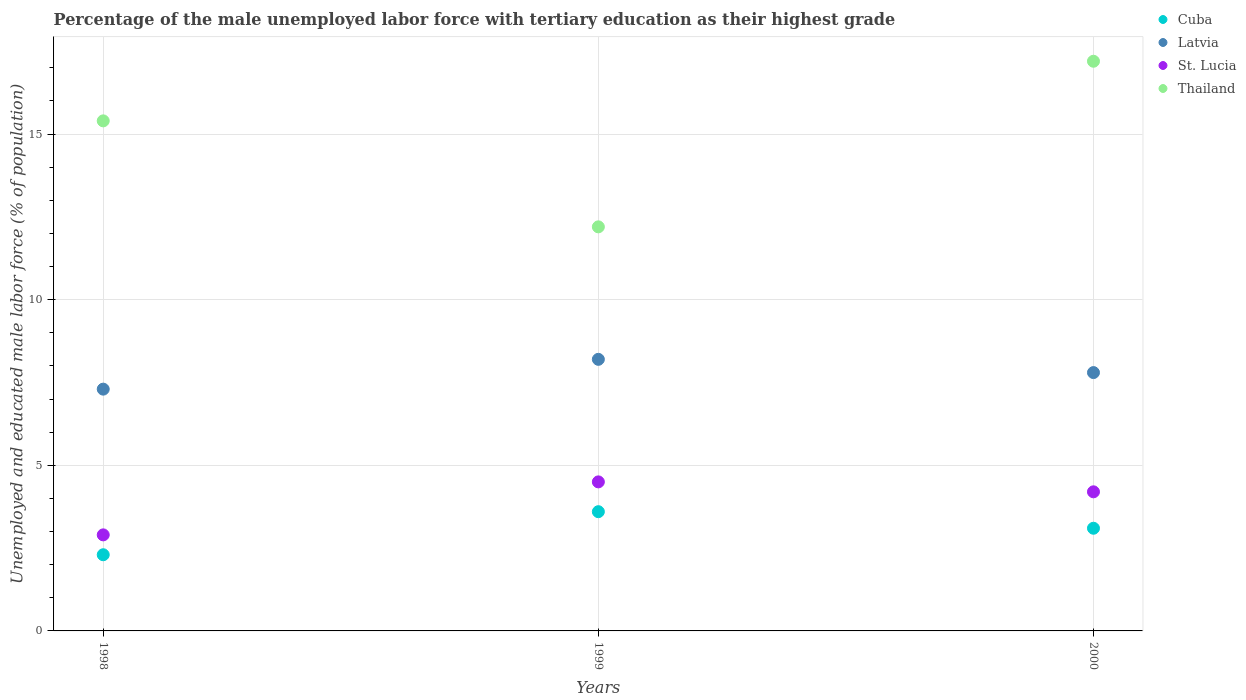What is the percentage of the unemployed male labor force with tertiary education in Latvia in 1998?
Your answer should be very brief. 7.3. Across all years, what is the maximum percentage of the unemployed male labor force with tertiary education in Cuba?
Your answer should be very brief. 3.6. Across all years, what is the minimum percentage of the unemployed male labor force with tertiary education in Thailand?
Give a very brief answer. 12.2. What is the total percentage of the unemployed male labor force with tertiary education in Cuba in the graph?
Provide a short and direct response. 9. What is the difference between the percentage of the unemployed male labor force with tertiary education in Cuba in 1998 and that in 1999?
Your answer should be very brief. -1.3. What is the difference between the percentage of the unemployed male labor force with tertiary education in Latvia in 1998 and the percentage of the unemployed male labor force with tertiary education in Cuba in 1999?
Your answer should be compact. 3.7. What is the average percentage of the unemployed male labor force with tertiary education in Latvia per year?
Provide a short and direct response. 7.77. In the year 2000, what is the difference between the percentage of the unemployed male labor force with tertiary education in Latvia and percentage of the unemployed male labor force with tertiary education in Cuba?
Provide a short and direct response. 4.7. What is the ratio of the percentage of the unemployed male labor force with tertiary education in Latvia in 1999 to that in 2000?
Keep it short and to the point. 1.05. What is the difference between the highest and the second highest percentage of the unemployed male labor force with tertiary education in Latvia?
Your answer should be very brief. 0.4. What is the difference between the highest and the lowest percentage of the unemployed male labor force with tertiary education in Thailand?
Your answer should be compact. 5. Is it the case that in every year, the sum of the percentage of the unemployed male labor force with tertiary education in Cuba and percentage of the unemployed male labor force with tertiary education in St. Lucia  is greater than the sum of percentage of the unemployed male labor force with tertiary education in Latvia and percentage of the unemployed male labor force with tertiary education in Thailand?
Make the answer very short. No. Is it the case that in every year, the sum of the percentage of the unemployed male labor force with tertiary education in St. Lucia and percentage of the unemployed male labor force with tertiary education in Cuba  is greater than the percentage of the unemployed male labor force with tertiary education in Thailand?
Keep it short and to the point. No. Is the percentage of the unemployed male labor force with tertiary education in Cuba strictly less than the percentage of the unemployed male labor force with tertiary education in Latvia over the years?
Provide a succinct answer. Yes. How many dotlines are there?
Provide a short and direct response. 4. Are the values on the major ticks of Y-axis written in scientific E-notation?
Your answer should be compact. No. Does the graph contain grids?
Make the answer very short. Yes. Where does the legend appear in the graph?
Offer a very short reply. Top right. How are the legend labels stacked?
Provide a short and direct response. Vertical. What is the title of the graph?
Make the answer very short. Percentage of the male unemployed labor force with tertiary education as their highest grade. Does "Poland" appear as one of the legend labels in the graph?
Ensure brevity in your answer.  No. What is the label or title of the Y-axis?
Provide a short and direct response. Unemployed and educated male labor force (% of population). What is the Unemployed and educated male labor force (% of population) in Cuba in 1998?
Give a very brief answer. 2.3. What is the Unemployed and educated male labor force (% of population) in Latvia in 1998?
Offer a very short reply. 7.3. What is the Unemployed and educated male labor force (% of population) in St. Lucia in 1998?
Give a very brief answer. 2.9. What is the Unemployed and educated male labor force (% of population) in Thailand in 1998?
Make the answer very short. 15.4. What is the Unemployed and educated male labor force (% of population) in Cuba in 1999?
Keep it short and to the point. 3.6. What is the Unemployed and educated male labor force (% of population) in Latvia in 1999?
Your answer should be very brief. 8.2. What is the Unemployed and educated male labor force (% of population) in St. Lucia in 1999?
Your answer should be compact. 4.5. What is the Unemployed and educated male labor force (% of population) of Thailand in 1999?
Ensure brevity in your answer.  12.2. What is the Unemployed and educated male labor force (% of population) of Cuba in 2000?
Your response must be concise. 3.1. What is the Unemployed and educated male labor force (% of population) of Latvia in 2000?
Provide a succinct answer. 7.8. What is the Unemployed and educated male labor force (% of population) in St. Lucia in 2000?
Offer a very short reply. 4.2. What is the Unemployed and educated male labor force (% of population) of Thailand in 2000?
Offer a very short reply. 17.2. Across all years, what is the maximum Unemployed and educated male labor force (% of population) of Cuba?
Your answer should be very brief. 3.6. Across all years, what is the maximum Unemployed and educated male labor force (% of population) in Latvia?
Provide a short and direct response. 8.2. Across all years, what is the maximum Unemployed and educated male labor force (% of population) in Thailand?
Keep it short and to the point. 17.2. Across all years, what is the minimum Unemployed and educated male labor force (% of population) in Cuba?
Your response must be concise. 2.3. Across all years, what is the minimum Unemployed and educated male labor force (% of population) of Latvia?
Offer a terse response. 7.3. Across all years, what is the minimum Unemployed and educated male labor force (% of population) of St. Lucia?
Your answer should be compact. 2.9. Across all years, what is the minimum Unemployed and educated male labor force (% of population) in Thailand?
Provide a succinct answer. 12.2. What is the total Unemployed and educated male labor force (% of population) of Latvia in the graph?
Ensure brevity in your answer.  23.3. What is the total Unemployed and educated male labor force (% of population) of Thailand in the graph?
Keep it short and to the point. 44.8. What is the difference between the Unemployed and educated male labor force (% of population) of Thailand in 1998 and that in 1999?
Your response must be concise. 3.2. What is the difference between the Unemployed and educated male labor force (% of population) in Cuba in 1998 and that in 2000?
Your answer should be very brief. -0.8. What is the difference between the Unemployed and educated male labor force (% of population) of Thailand in 1998 and that in 2000?
Your answer should be very brief. -1.8. What is the difference between the Unemployed and educated male labor force (% of population) of Cuba in 1999 and that in 2000?
Keep it short and to the point. 0.5. What is the difference between the Unemployed and educated male labor force (% of population) of Latvia in 1999 and that in 2000?
Keep it short and to the point. 0.4. What is the difference between the Unemployed and educated male labor force (% of population) of St. Lucia in 1999 and that in 2000?
Make the answer very short. 0.3. What is the difference between the Unemployed and educated male labor force (% of population) of Thailand in 1999 and that in 2000?
Keep it short and to the point. -5. What is the difference between the Unemployed and educated male labor force (% of population) of Cuba in 1998 and the Unemployed and educated male labor force (% of population) of Latvia in 1999?
Make the answer very short. -5.9. What is the difference between the Unemployed and educated male labor force (% of population) in Cuba in 1998 and the Unemployed and educated male labor force (% of population) in St. Lucia in 1999?
Provide a succinct answer. -2.2. What is the difference between the Unemployed and educated male labor force (% of population) of Cuba in 1998 and the Unemployed and educated male labor force (% of population) of Thailand in 1999?
Provide a succinct answer. -9.9. What is the difference between the Unemployed and educated male labor force (% of population) in Cuba in 1998 and the Unemployed and educated male labor force (% of population) in Latvia in 2000?
Provide a short and direct response. -5.5. What is the difference between the Unemployed and educated male labor force (% of population) in Cuba in 1998 and the Unemployed and educated male labor force (% of population) in St. Lucia in 2000?
Offer a terse response. -1.9. What is the difference between the Unemployed and educated male labor force (% of population) in Cuba in 1998 and the Unemployed and educated male labor force (% of population) in Thailand in 2000?
Your answer should be compact. -14.9. What is the difference between the Unemployed and educated male labor force (% of population) in Latvia in 1998 and the Unemployed and educated male labor force (% of population) in St. Lucia in 2000?
Offer a terse response. 3.1. What is the difference between the Unemployed and educated male labor force (% of population) of St. Lucia in 1998 and the Unemployed and educated male labor force (% of population) of Thailand in 2000?
Provide a succinct answer. -14.3. What is the difference between the Unemployed and educated male labor force (% of population) in Cuba in 1999 and the Unemployed and educated male labor force (% of population) in St. Lucia in 2000?
Your answer should be compact. -0.6. What is the difference between the Unemployed and educated male labor force (% of population) in Cuba in 1999 and the Unemployed and educated male labor force (% of population) in Thailand in 2000?
Provide a short and direct response. -13.6. What is the difference between the Unemployed and educated male labor force (% of population) in Latvia in 1999 and the Unemployed and educated male labor force (% of population) in St. Lucia in 2000?
Offer a very short reply. 4. What is the difference between the Unemployed and educated male labor force (% of population) in St. Lucia in 1999 and the Unemployed and educated male labor force (% of population) in Thailand in 2000?
Make the answer very short. -12.7. What is the average Unemployed and educated male labor force (% of population) of Latvia per year?
Give a very brief answer. 7.77. What is the average Unemployed and educated male labor force (% of population) of St. Lucia per year?
Ensure brevity in your answer.  3.87. What is the average Unemployed and educated male labor force (% of population) in Thailand per year?
Ensure brevity in your answer.  14.93. In the year 1998, what is the difference between the Unemployed and educated male labor force (% of population) of Cuba and Unemployed and educated male labor force (% of population) of St. Lucia?
Offer a very short reply. -0.6. In the year 1998, what is the difference between the Unemployed and educated male labor force (% of population) in Cuba and Unemployed and educated male labor force (% of population) in Thailand?
Offer a very short reply. -13.1. In the year 1998, what is the difference between the Unemployed and educated male labor force (% of population) of Latvia and Unemployed and educated male labor force (% of population) of St. Lucia?
Provide a short and direct response. 4.4. In the year 1999, what is the difference between the Unemployed and educated male labor force (% of population) in Cuba and Unemployed and educated male labor force (% of population) in St. Lucia?
Provide a succinct answer. -0.9. In the year 1999, what is the difference between the Unemployed and educated male labor force (% of population) in Latvia and Unemployed and educated male labor force (% of population) in St. Lucia?
Offer a very short reply. 3.7. In the year 2000, what is the difference between the Unemployed and educated male labor force (% of population) in Cuba and Unemployed and educated male labor force (% of population) in Latvia?
Provide a short and direct response. -4.7. In the year 2000, what is the difference between the Unemployed and educated male labor force (% of population) of Cuba and Unemployed and educated male labor force (% of population) of Thailand?
Your answer should be very brief. -14.1. In the year 2000, what is the difference between the Unemployed and educated male labor force (% of population) in Latvia and Unemployed and educated male labor force (% of population) in St. Lucia?
Give a very brief answer. 3.6. What is the ratio of the Unemployed and educated male labor force (% of population) of Cuba in 1998 to that in 1999?
Provide a short and direct response. 0.64. What is the ratio of the Unemployed and educated male labor force (% of population) in Latvia in 1998 to that in 1999?
Your answer should be very brief. 0.89. What is the ratio of the Unemployed and educated male labor force (% of population) of St. Lucia in 1998 to that in 1999?
Ensure brevity in your answer.  0.64. What is the ratio of the Unemployed and educated male labor force (% of population) in Thailand in 1998 to that in 1999?
Provide a short and direct response. 1.26. What is the ratio of the Unemployed and educated male labor force (% of population) in Cuba in 1998 to that in 2000?
Make the answer very short. 0.74. What is the ratio of the Unemployed and educated male labor force (% of population) of Latvia in 1998 to that in 2000?
Offer a terse response. 0.94. What is the ratio of the Unemployed and educated male labor force (% of population) in St. Lucia in 1998 to that in 2000?
Your response must be concise. 0.69. What is the ratio of the Unemployed and educated male labor force (% of population) of Thailand in 1998 to that in 2000?
Offer a very short reply. 0.9. What is the ratio of the Unemployed and educated male labor force (% of population) in Cuba in 1999 to that in 2000?
Provide a short and direct response. 1.16. What is the ratio of the Unemployed and educated male labor force (% of population) in Latvia in 1999 to that in 2000?
Make the answer very short. 1.05. What is the ratio of the Unemployed and educated male labor force (% of population) of St. Lucia in 1999 to that in 2000?
Your answer should be very brief. 1.07. What is the ratio of the Unemployed and educated male labor force (% of population) of Thailand in 1999 to that in 2000?
Provide a short and direct response. 0.71. What is the difference between the highest and the second highest Unemployed and educated male labor force (% of population) in Latvia?
Make the answer very short. 0.4. What is the difference between the highest and the second highest Unemployed and educated male labor force (% of population) in St. Lucia?
Ensure brevity in your answer.  0.3. What is the difference between the highest and the lowest Unemployed and educated male labor force (% of population) in Cuba?
Offer a very short reply. 1.3. What is the difference between the highest and the lowest Unemployed and educated male labor force (% of population) of St. Lucia?
Your response must be concise. 1.6. What is the difference between the highest and the lowest Unemployed and educated male labor force (% of population) of Thailand?
Keep it short and to the point. 5. 